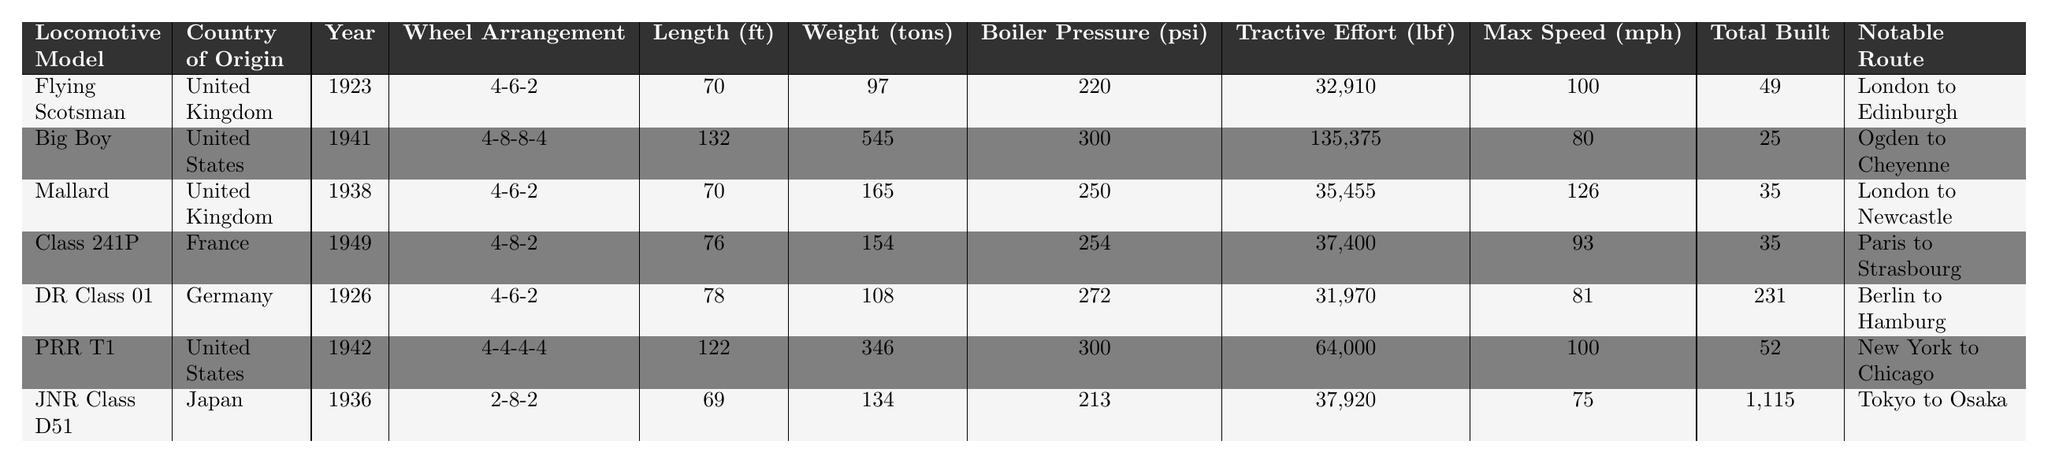What is the wheel arrangement of the Flying Scotsman? The table explicitly lists the wheel arrangement for each locomotive, and for the Flying Scotsman, it is stated as "4-6-2."
Answer: 4-6-2 Which locomotive has the highest tractive effort? The table presents the tractive effort for each locomotive, with the Big Boy showing a value of 135,375 lbf, which is the highest among all listed models.
Answer: Big Boy How many locomotives were built for the JNR Class D51? According to the table, the total built for the JNR Class D51 is shown as 1,115.
Answer: 1,115 What is the average length of the locomotives listed? First, sum the lengths of all locomotives: (70 + 132 + 70 + 76 + 78 + 122 + 69) = 617. Then, divide by 7 (the number of locomotives) gives an average of 617/7 ≈ 88.14.
Answer: 88.14 Which locomotive has the lowest maximum speed and what is that speed? By examining the maximum speed column, the lowest speed is observed for the JNR Class D51, which has a maximum speed of 75 mph.
Answer: 75 mph Is the boiler pressure of the PRR T1 higher than that of the Mallard? Comparing the boiler pressures directly from the table shows that the PRR T1 has a pressure of 300 psi, while the Mallard has 250 psi, confirming that the PRR T1 has a higher boiler pressure.
Answer: Yes What is the total weight of locomotives with a wheel arrangement of 4-6-2? The weights for locomotives with a wheel arrangement of 4-6-2 are: Flying Scotsman (97 tons) + Mallard (165 tons) + DR Class 01 (108 tons) = 370 tons total.
Answer: 370 tons Which route connects the Flying Scotsman and Mallard? Looking at the notable routes provided, both locomotives operate on distinct routes, with no overlap; thus, there is no connecting route between them.
Answer: No connecting route What is the difference in boiler pressure between the Class 241P and the Big Boy? The boiler pressure for Class 241P is 254 psi, and for Big Boy, it is 300 psi. The difference is calculated as 300 - 254 = 46 psi.
Answer: 46 psi Which country produced the Class 241P locomotive? The table indicates that the Class 241P was produced in France.
Answer: France 